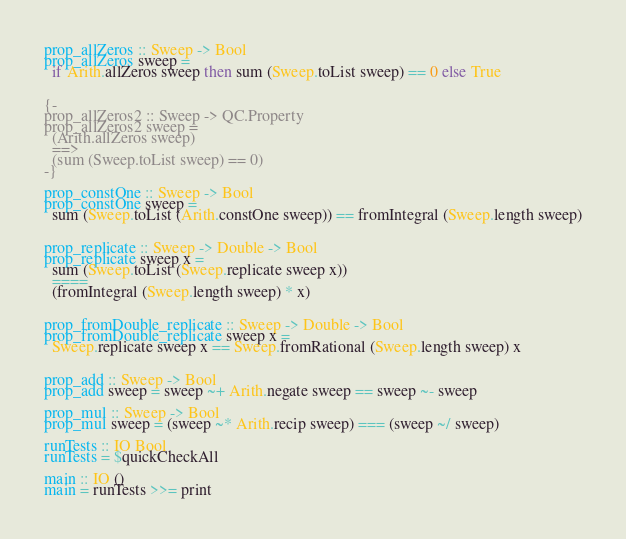Convert code to text. <code><loc_0><loc_0><loc_500><loc_500><_Haskell_>
prop_allZeros :: Sweep -> Bool
prop_allZeros sweep =
  if Arith.allZeros sweep then sum (Sweep.toList sweep) == 0 else True


{-
prop_allZeros2 :: Sweep -> QC.Property
prop_allZeros2 sweep =
  (Arith.allZeros sweep)
  ==>
  (sum (Sweep.toList sweep) == 0)
-}

prop_constOne :: Sweep -> Bool
prop_constOne sweep =
  sum (Sweep.toList (Arith.constOne sweep)) == fromIntegral (Sweep.length sweep)


prop_replicate :: Sweep -> Double -> Bool
prop_replicate sweep x =
  sum (Sweep.toList (Sweep.replicate sweep x))
  ====
  (fromIntegral (Sweep.length sweep) * x)


prop_fromDouble_replicate :: Sweep -> Double -> Bool
prop_fromDouble_replicate sweep x =
  Sweep.replicate sweep x == Sweep.fromRational (Sweep.length sweep) x


prop_add :: Sweep -> Bool
prop_add sweep = sweep ~+ Arith.negate sweep == sweep ~- sweep

prop_mul :: Sweep -> Bool
prop_mul sweep = (sweep ~* Arith.recip sweep) === (sweep ~/ sweep)

runTests :: IO Bool
runTests = $quickCheckAll

main :: IO ()
main = runTests >>= print
</code> 